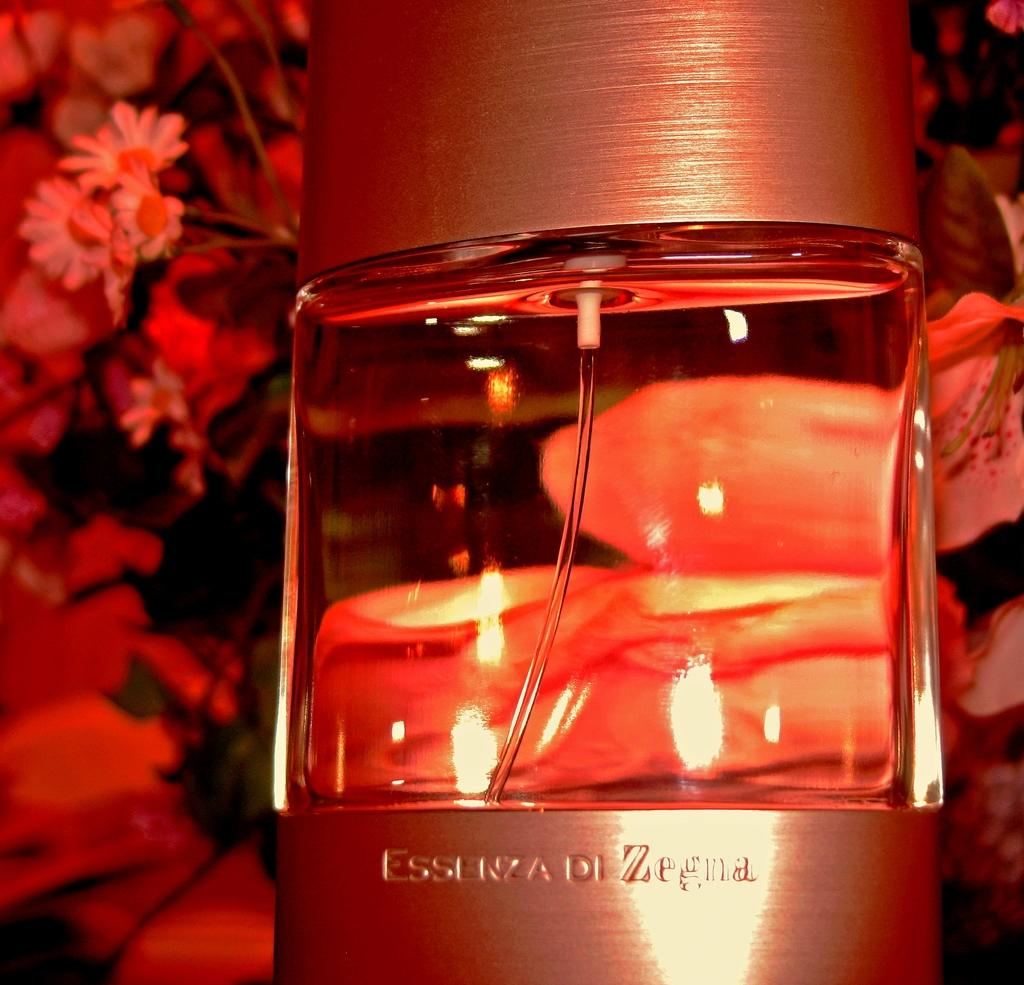<image>
Give a short and clear explanation of the subsequent image. Perfume named Essenza Di Zegna in front of flower background. 